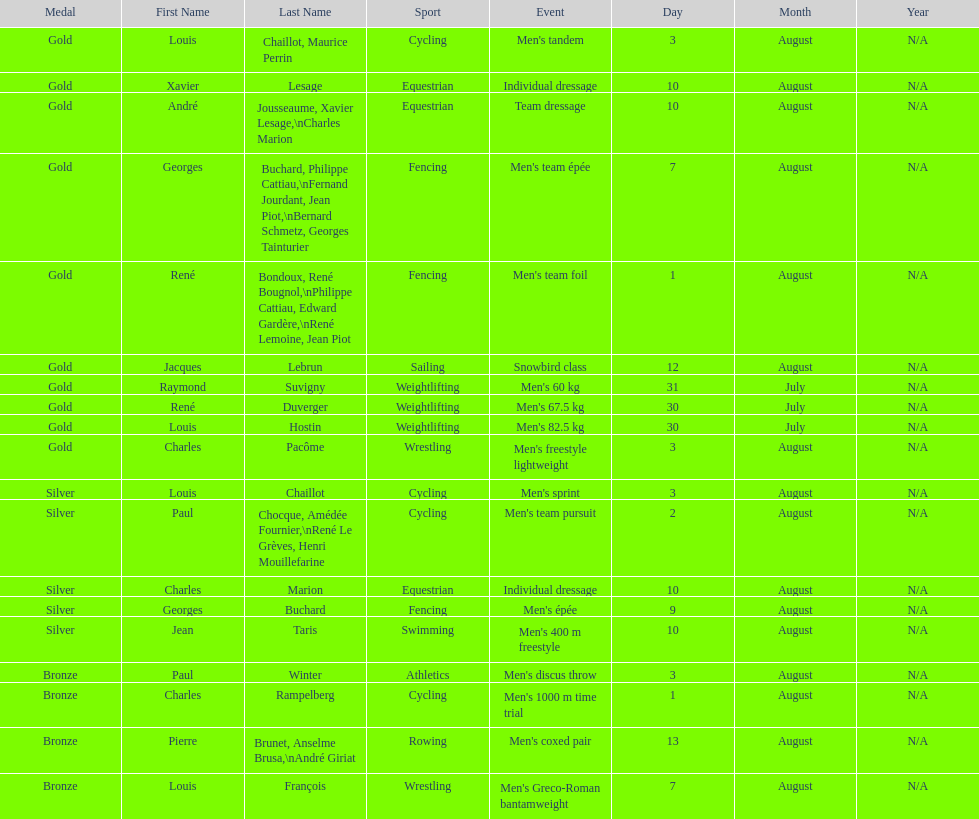How many gold medals did this country win during these olympics? 10. 